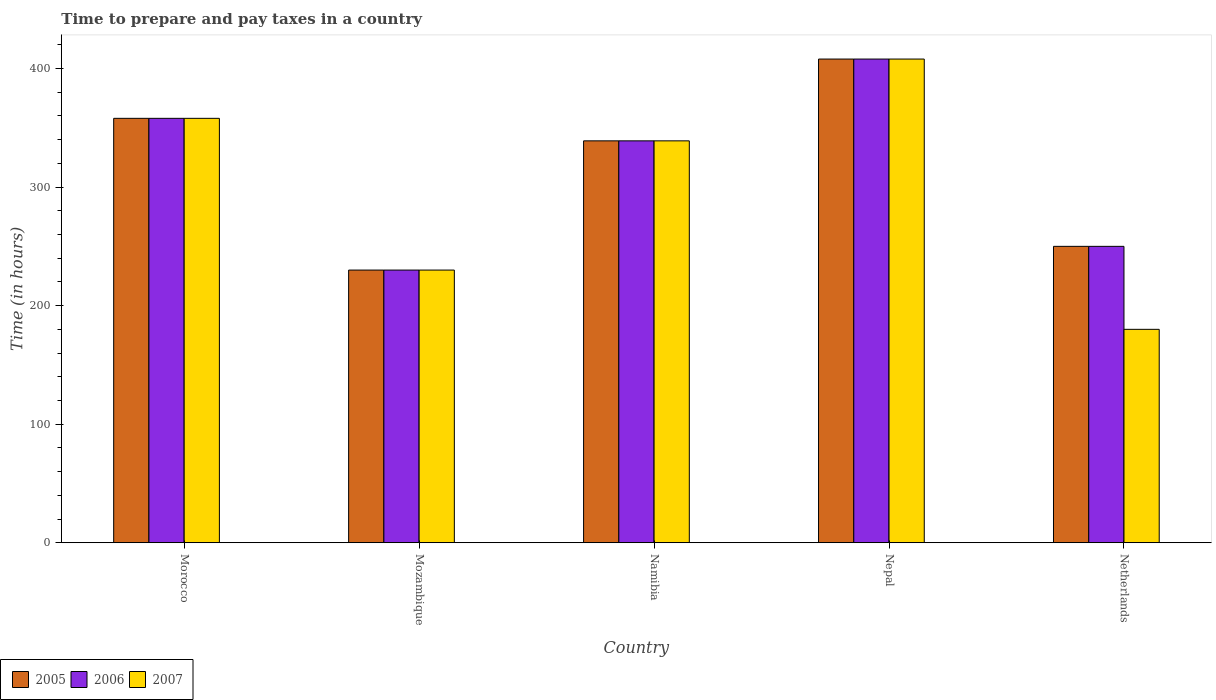How many bars are there on the 3rd tick from the right?
Keep it short and to the point. 3. What is the number of hours required to prepare and pay taxes in 2007 in Netherlands?
Keep it short and to the point. 180. Across all countries, what is the maximum number of hours required to prepare and pay taxes in 2007?
Give a very brief answer. 408. Across all countries, what is the minimum number of hours required to prepare and pay taxes in 2005?
Provide a succinct answer. 230. In which country was the number of hours required to prepare and pay taxes in 2007 maximum?
Offer a very short reply. Nepal. In which country was the number of hours required to prepare and pay taxes in 2007 minimum?
Give a very brief answer. Netherlands. What is the total number of hours required to prepare and pay taxes in 2006 in the graph?
Your response must be concise. 1585. What is the difference between the number of hours required to prepare and pay taxes in 2005 in Morocco and that in Namibia?
Your answer should be very brief. 19. What is the difference between the number of hours required to prepare and pay taxes in 2006 in Mozambique and the number of hours required to prepare and pay taxes in 2007 in Nepal?
Make the answer very short. -178. What is the average number of hours required to prepare and pay taxes in 2005 per country?
Ensure brevity in your answer.  317. What is the difference between the number of hours required to prepare and pay taxes of/in 2005 and number of hours required to prepare and pay taxes of/in 2007 in Nepal?
Offer a very short reply. 0. What is the ratio of the number of hours required to prepare and pay taxes in 2006 in Mozambique to that in Namibia?
Offer a terse response. 0.68. Is the number of hours required to prepare and pay taxes in 2005 in Nepal less than that in Netherlands?
Your response must be concise. No. Is the difference between the number of hours required to prepare and pay taxes in 2005 in Morocco and Netherlands greater than the difference between the number of hours required to prepare and pay taxes in 2007 in Morocco and Netherlands?
Provide a succinct answer. No. What is the difference between the highest and the second highest number of hours required to prepare and pay taxes in 2006?
Offer a terse response. 69. What is the difference between the highest and the lowest number of hours required to prepare and pay taxes in 2006?
Ensure brevity in your answer.  178. Is the sum of the number of hours required to prepare and pay taxes in 2006 in Nepal and Netherlands greater than the maximum number of hours required to prepare and pay taxes in 2007 across all countries?
Make the answer very short. Yes. How many bars are there?
Offer a very short reply. 15. Does the graph contain any zero values?
Ensure brevity in your answer.  No. Does the graph contain grids?
Offer a terse response. No. Where does the legend appear in the graph?
Offer a very short reply. Bottom left. What is the title of the graph?
Offer a very short reply. Time to prepare and pay taxes in a country. Does "1961" appear as one of the legend labels in the graph?
Your answer should be compact. No. What is the label or title of the X-axis?
Your answer should be compact. Country. What is the label or title of the Y-axis?
Provide a succinct answer. Time (in hours). What is the Time (in hours) of 2005 in Morocco?
Your answer should be compact. 358. What is the Time (in hours) in 2006 in Morocco?
Make the answer very short. 358. What is the Time (in hours) in 2007 in Morocco?
Offer a terse response. 358. What is the Time (in hours) of 2005 in Mozambique?
Make the answer very short. 230. What is the Time (in hours) of 2006 in Mozambique?
Provide a succinct answer. 230. What is the Time (in hours) of 2007 in Mozambique?
Your answer should be compact. 230. What is the Time (in hours) of 2005 in Namibia?
Offer a very short reply. 339. What is the Time (in hours) in 2006 in Namibia?
Ensure brevity in your answer.  339. What is the Time (in hours) of 2007 in Namibia?
Offer a very short reply. 339. What is the Time (in hours) in 2005 in Nepal?
Offer a very short reply. 408. What is the Time (in hours) of 2006 in Nepal?
Provide a short and direct response. 408. What is the Time (in hours) in 2007 in Nepal?
Give a very brief answer. 408. What is the Time (in hours) in 2005 in Netherlands?
Offer a very short reply. 250. What is the Time (in hours) in 2006 in Netherlands?
Ensure brevity in your answer.  250. What is the Time (in hours) in 2007 in Netherlands?
Offer a very short reply. 180. Across all countries, what is the maximum Time (in hours) in 2005?
Your answer should be compact. 408. Across all countries, what is the maximum Time (in hours) in 2006?
Make the answer very short. 408. Across all countries, what is the maximum Time (in hours) of 2007?
Your response must be concise. 408. Across all countries, what is the minimum Time (in hours) of 2005?
Offer a terse response. 230. Across all countries, what is the minimum Time (in hours) of 2006?
Provide a succinct answer. 230. Across all countries, what is the minimum Time (in hours) of 2007?
Your response must be concise. 180. What is the total Time (in hours) in 2005 in the graph?
Your answer should be very brief. 1585. What is the total Time (in hours) of 2006 in the graph?
Provide a succinct answer. 1585. What is the total Time (in hours) of 2007 in the graph?
Keep it short and to the point. 1515. What is the difference between the Time (in hours) of 2005 in Morocco and that in Mozambique?
Your answer should be compact. 128. What is the difference between the Time (in hours) of 2006 in Morocco and that in Mozambique?
Your answer should be compact. 128. What is the difference between the Time (in hours) of 2007 in Morocco and that in Mozambique?
Provide a short and direct response. 128. What is the difference between the Time (in hours) of 2005 in Morocco and that in Namibia?
Give a very brief answer. 19. What is the difference between the Time (in hours) of 2007 in Morocco and that in Namibia?
Offer a terse response. 19. What is the difference between the Time (in hours) of 2005 in Morocco and that in Nepal?
Your answer should be compact. -50. What is the difference between the Time (in hours) of 2007 in Morocco and that in Nepal?
Ensure brevity in your answer.  -50. What is the difference between the Time (in hours) of 2005 in Morocco and that in Netherlands?
Offer a terse response. 108. What is the difference between the Time (in hours) of 2006 in Morocco and that in Netherlands?
Provide a succinct answer. 108. What is the difference between the Time (in hours) of 2007 in Morocco and that in Netherlands?
Your answer should be compact. 178. What is the difference between the Time (in hours) of 2005 in Mozambique and that in Namibia?
Your response must be concise. -109. What is the difference between the Time (in hours) in 2006 in Mozambique and that in Namibia?
Your answer should be very brief. -109. What is the difference between the Time (in hours) in 2007 in Mozambique and that in Namibia?
Offer a terse response. -109. What is the difference between the Time (in hours) of 2005 in Mozambique and that in Nepal?
Make the answer very short. -178. What is the difference between the Time (in hours) in 2006 in Mozambique and that in Nepal?
Your response must be concise. -178. What is the difference between the Time (in hours) in 2007 in Mozambique and that in Nepal?
Your response must be concise. -178. What is the difference between the Time (in hours) of 2005 in Mozambique and that in Netherlands?
Make the answer very short. -20. What is the difference between the Time (in hours) in 2006 in Mozambique and that in Netherlands?
Keep it short and to the point. -20. What is the difference between the Time (in hours) of 2005 in Namibia and that in Nepal?
Provide a short and direct response. -69. What is the difference between the Time (in hours) in 2006 in Namibia and that in Nepal?
Make the answer very short. -69. What is the difference between the Time (in hours) of 2007 in Namibia and that in Nepal?
Ensure brevity in your answer.  -69. What is the difference between the Time (in hours) in 2005 in Namibia and that in Netherlands?
Offer a very short reply. 89. What is the difference between the Time (in hours) in 2006 in Namibia and that in Netherlands?
Make the answer very short. 89. What is the difference between the Time (in hours) in 2007 in Namibia and that in Netherlands?
Ensure brevity in your answer.  159. What is the difference between the Time (in hours) in 2005 in Nepal and that in Netherlands?
Your response must be concise. 158. What is the difference between the Time (in hours) in 2006 in Nepal and that in Netherlands?
Provide a short and direct response. 158. What is the difference between the Time (in hours) of 2007 in Nepal and that in Netherlands?
Offer a terse response. 228. What is the difference between the Time (in hours) of 2005 in Morocco and the Time (in hours) of 2006 in Mozambique?
Provide a short and direct response. 128. What is the difference between the Time (in hours) of 2005 in Morocco and the Time (in hours) of 2007 in Mozambique?
Provide a succinct answer. 128. What is the difference between the Time (in hours) of 2006 in Morocco and the Time (in hours) of 2007 in Mozambique?
Provide a succinct answer. 128. What is the difference between the Time (in hours) in 2006 in Morocco and the Time (in hours) in 2007 in Namibia?
Provide a succinct answer. 19. What is the difference between the Time (in hours) of 2005 in Morocco and the Time (in hours) of 2006 in Nepal?
Offer a terse response. -50. What is the difference between the Time (in hours) in 2005 in Morocco and the Time (in hours) in 2007 in Nepal?
Ensure brevity in your answer.  -50. What is the difference between the Time (in hours) of 2005 in Morocco and the Time (in hours) of 2006 in Netherlands?
Offer a very short reply. 108. What is the difference between the Time (in hours) of 2005 in Morocco and the Time (in hours) of 2007 in Netherlands?
Give a very brief answer. 178. What is the difference between the Time (in hours) of 2006 in Morocco and the Time (in hours) of 2007 in Netherlands?
Provide a short and direct response. 178. What is the difference between the Time (in hours) in 2005 in Mozambique and the Time (in hours) in 2006 in Namibia?
Your answer should be very brief. -109. What is the difference between the Time (in hours) in 2005 in Mozambique and the Time (in hours) in 2007 in Namibia?
Your response must be concise. -109. What is the difference between the Time (in hours) in 2006 in Mozambique and the Time (in hours) in 2007 in Namibia?
Your answer should be very brief. -109. What is the difference between the Time (in hours) of 2005 in Mozambique and the Time (in hours) of 2006 in Nepal?
Provide a succinct answer. -178. What is the difference between the Time (in hours) in 2005 in Mozambique and the Time (in hours) in 2007 in Nepal?
Make the answer very short. -178. What is the difference between the Time (in hours) of 2006 in Mozambique and the Time (in hours) of 2007 in Nepal?
Offer a very short reply. -178. What is the difference between the Time (in hours) of 2005 in Mozambique and the Time (in hours) of 2006 in Netherlands?
Provide a short and direct response. -20. What is the difference between the Time (in hours) of 2005 in Mozambique and the Time (in hours) of 2007 in Netherlands?
Your answer should be compact. 50. What is the difference between the Time (in hours) in 2006 in Mozambique and the Time (in hours) in 2007 in Netherlands?
Provide a short and direct response. 50. What is the difference between the Time (in hours) of 2005 in Namibia and the Time (in hours) of 2006 in Nepal?
Offer a very short reply. -69. What is the difference between the Time (in hours) of 2005 in Namibia and the Time (in hours) of 2007 in Nepal?
Ensure brevity in your answer.  -69. What is the difference between the Time (in hours) of 2006 in Namibia and the Time (in hours) of 2007 in Nepal?
Your answer should be very brief. -69. What is the difference between the Time (in hours) of 2005 in Namibia and the Time (in hours) of 2006 in Netherlands?
Offer a terse response. 89. What is the difference between the Time (in hours) in 2005 in Namibia and the Time (in hours) in 2007 in Netherlands?
Your response must be concise. 159. What is the difference between the Time (in hours) in 2006 in Namibia and the Time (in hours) in 2007 in Netherlands?
Provide a short and direct response. 159. What is the difference between the Time (in hours) of 2005 in Nepal and the Time (in hours) of 2006 in Netherlands?
Keep it short and to the point. 158. What is the difference between the Time (in hours) of 2005 in Nepal and the Time (in hours) of 2007 in Netherlands?
Provide a short and direct response. 228. What is the difference between the Time (in hours) of 2006 in Nepal and the Time (in hours) of 2007 in Netherlands?
Give a very brief answer. 228. What is the average Time (in hours) of 2005 per country?
Keep it short and to the point. 317. What is the average Time (in hours) of 2006 per country?
Provide a succinct answer. 317. What is the average Time (in hours) in 2007 per country?
Keep it short and to the point. 303. What is the difference between the Time (in hours) of 2005 and Time (in hours) of 2006 in Morocco?
Provide a short and direct response. 0. What is the difference between the Time (in hours) of 2005 and Time (in hours) of 2007 in Morocco?
Offer a very short reply. 0. What is the difference between the Time (in hours) in 2005 and Time (in hours) in 2007 in Mozambique?
Your answer should be very brief. 0. What is the difference between the Time (in hours) of 2006 and Time (in hours) of 2007 in Mozambique?
Give a very brief answer. 0. What is the difference between the Time (in hours) in 2005 and Time (in hours) in 2007 in Netherlands?
Your response must be concise. 70. What is the ratio of the Time (in hours) in 2005 in Morocco to that in Mozambique?
Provide a succinct answer. 1.56. What is the ratio of the Time (in hours) in 2006 in Morocco to that in Mozambique?
Your answer should be very brief. 1.56. What is the ratio of the Time (in hours) in 2007 in Morocco to that in Mozambique?
Make the answer very short. 1.56. What is the ratio of the Time (in hours) of 2005 in Morocco to that in Namibia?
Keep it short and to the point. 1.06. What is the ratio of the Time (in hours) of 2006 in Morocco to that in Namibia?
Offer a terse response. 1.06. What is the ratio of the Time (in hours) of 2007 in Morocco to that in Namibia?
Your response must be concise. 1.06. What is the ratio of the Time (in hours) in 2005 in Morocco to that in Nepal?
Offer a very short reply. 0.88. What is the ratio of the Time (in hours) in 2006 in Morocco to that in Nepal?
Your answer should be compact. 0.88. What is the ratio of the Time (in hours) in 2007 in Morocco to that in Nepal?
Provide a short and direct response. 0.88. What is the ratio of the Time (in hours) of 2005 in Morocco to that in Netherlands?
Your answer should be compact. 1.43. What is the ratio of the Time (in hours) of 2006 in Morocco to that in Netherlands?
Your response must be concise. 1.43. What is the ratio of the Time (in hours) of 2007 in Morocco to that in Netherlands?
Ensure brevity in your answer.  1.99. What is the ratio of the Time (in hours) in 2005 in Mozambique to that in Namibia?
Keep it short and to the point. 0.68. What is the ratio of the Time (in hours) in 2006 in Mozambique to that in Namibia?
Make the answer very short. 0.68. What is the ratio of the Time (in hours) in 2007 in Mozambique to that in Namibia?
Your answer should be compact. 0.68. What is the ratio of the Time (in hours) in 2005 in Mozambique to that in Nepal?
Provide a succinct answer. 0.56. What is the ratio of the Time (in hours) of 2006 in Mozambique to that in Nepal?
Keep it short and to the point. 0.56. What is the ratio of the Time (in hours) of 2007 in Mozambique to that in Nepal?
Provide a short and direct response. 0.56. What is the ratio of the Time (in hours) of 2007 in Mozambique to that in Netherlands?
Your answer should be compact. 1.28. What is the ratio of the Time (in hours) of 2005 in Namibia to that in Nepal?
Your answer should be very brief. 0.83. What is the ratio of the Time (in hours) of 2006 in Namibia to that in Nepal?
Make the answer very short. 0.83. What is the ratio of the Time (in hours) of 2007 in Namibia to that in Nepal?
Your response must be concise. 0.83. What is the ratio of the Time (in hours) in 2005 in Namibia to that in Netherlands?
Your answer should be very brief. 1.36. What is the ratio of the Time (in hours) of 2006 in Namibia to that in Netherlands?
Offer a terse response. 1.36. What is the ratio of the Time (in hours) of 2007 in Namibia to that in Netherlands?
Ensure brevity in your answer.  1.88. What is the ratio of the Time (in hours) of 2005 in Nepal to that in Netherlands?
Your answer should be compact. 1.63. What is the ratio of the Time (in hours) in 2006 in Nepal to that in Netherlands?
Offer a very short reply. 1.63. What is the ratio of the Time (in hours) of 2007 in Nepal to that in Netherlands?
Give a very brief answer. 2.27. What is the difference between the highest and the lowest Time (in hours) of 2005?
Ensure brevity in your answer.  178. What is the difference between the highest and the lowest Time (in hours) in 2006?
Offer a very short reply. 178. What is the difference between the highest and the lowest Time (in hours) of 2007?
Give a very brief answer. 228. 